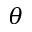Convert formula to latex. <formula><loc_0><loc_0><loc_500><loc_500>\theta</formula> 